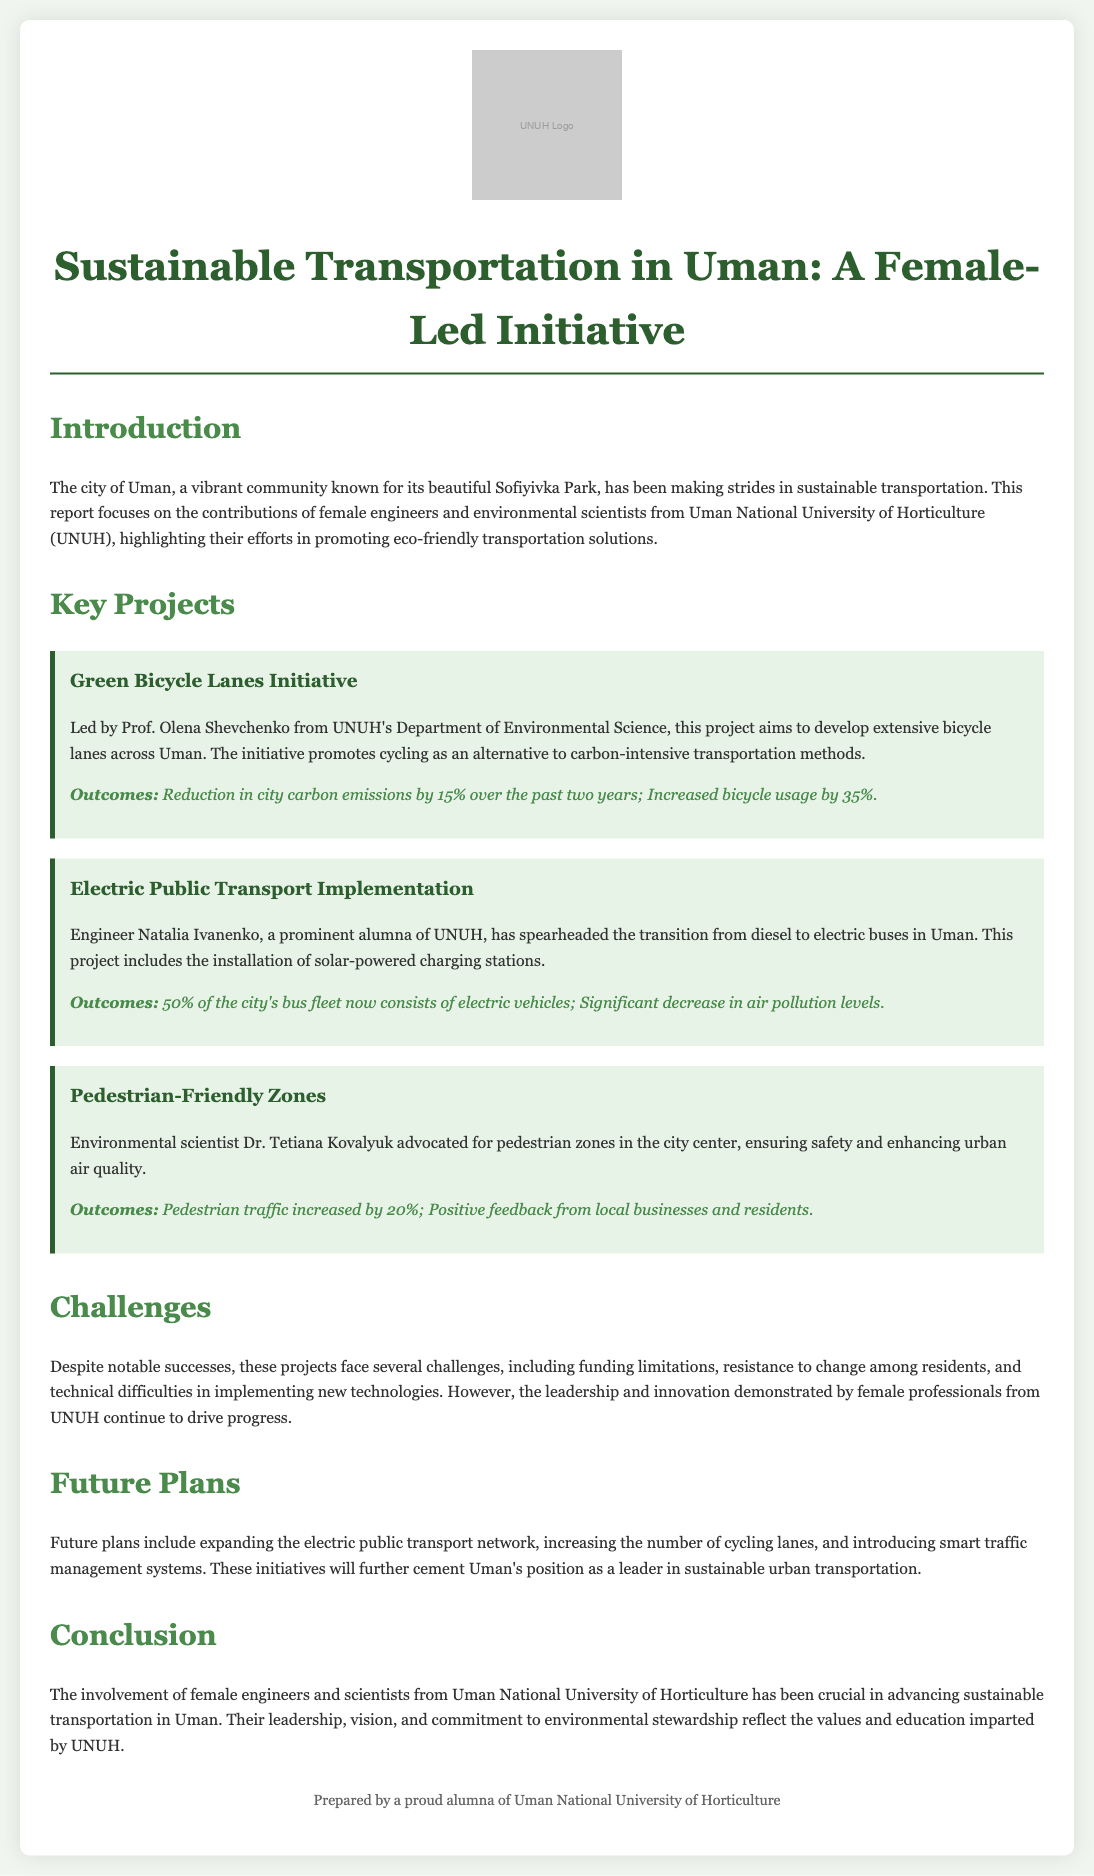What is the title of the report? The title of the report indicates the focus on sustainable transportation and female leadership in Uman.
Answer: Sustainable Transportation in Uman: A Female-Led Initiative Who leads the Green Bicycle Lanes Initiative? The project details indicate that Prof. Olena Shevchenko leads the initiative.
Answer: Prof. Olena Shevchenko What percentage reduction in carbon emissions has been achieved? The outcomes of the Green Bicycle Lanes Initiative state a 15% reduction in carbon emissions.
Answer: 15% How many electric vehicles are now part of the city's bus fleet? The document mentions that 50% of the bus fleet now consists of electric vehicles.
Answer: 50% What is one challenge mentioned in the report? The report identifies various challenges, including funding limitations.
Answer: Funding limitations What future plan is proposed regarding public transport? The document outlines plans to expand the electric public transport network as a future initiative.
Answer: Expand the electric public transport network What is the increase in bicycle usage attributed to the Green Bicycle Lanes Initiative? The report states that there has been a 35% increase in bicycle usage due to this initiative.
Answer: 35% What positive feedback has been received about the pedestrian zones? The outcomes state that there was positive feedback from local businesses and residents about the pedestrian zones.
Answer: Positive feedback Who is the prominent alumna mentioned in the report? The report highlights Engineer Natalia Ivanenko as a prominent alumna of UNUH.
Answer: Engineer Natalia Ivanenko 